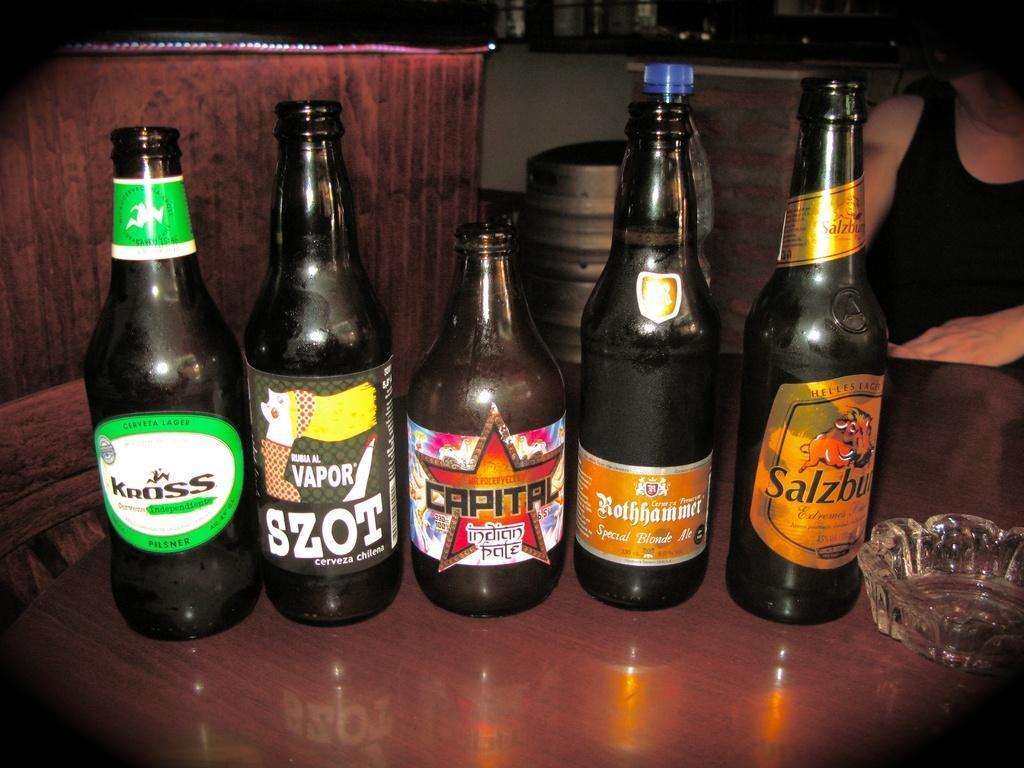Describe this image in one or two sentences. In this image we can see five bottles with labels on it and an ashtray placed on the table. In the background we can see a person. 